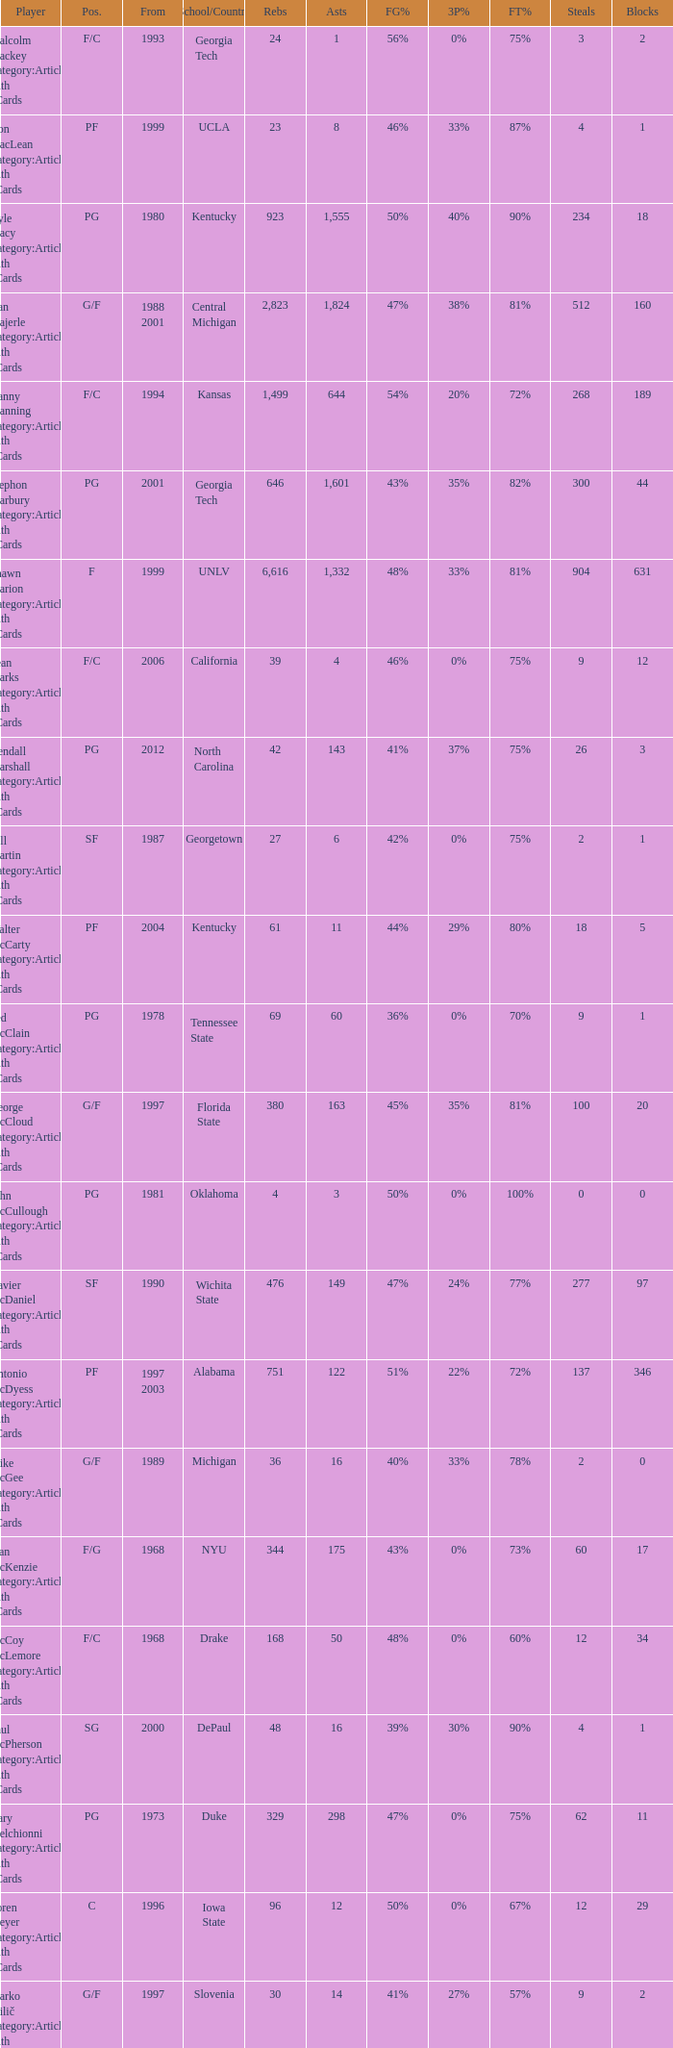What position does the player from arkansas play? C. 